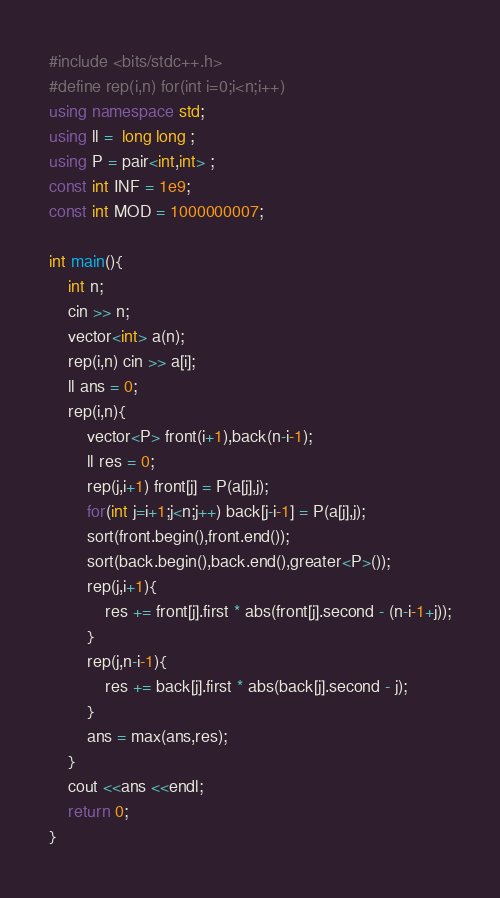<code> <loc_0><loc_0><loc_500><loc_500><_C++_>#include <bits/stdc++.h>
#define rep(i,n) for(int i=0;i<n;i++)
using namespace std;
using ll =  long long ;
using P = pair<int,int> ;
const int INF = 1e9;
const int MOD = 1000000007;

int main(){
    int n;
    cin >> n;
    vector<int> a(n);
    rep(i,n) cin >> a[i];
    ll ans = 0;
    rep(i,n){
        vector<P> front(i+1),back(n-i-1);
        ll res = 0;
        rep(j,i+1) front[j] = P(a[j],j);
        for(int j=i+1;j<n;j++) back[j-i-1] = P(a[j],j);
        sort(front.begin(),front.end());
        sort(back.begin(),back.end(),greater<P>());
        rep(j,i+1){
            res += front[j].first * abs(front[j].second - (n-i-1+j));
        }
        rep(j,n-i-1){
            res += back[j].first * abs(back[j].second - j);
        }
        ans = max(ans,res);
    }
    cout <<ans <<endl;
    return 0;
}</code> 